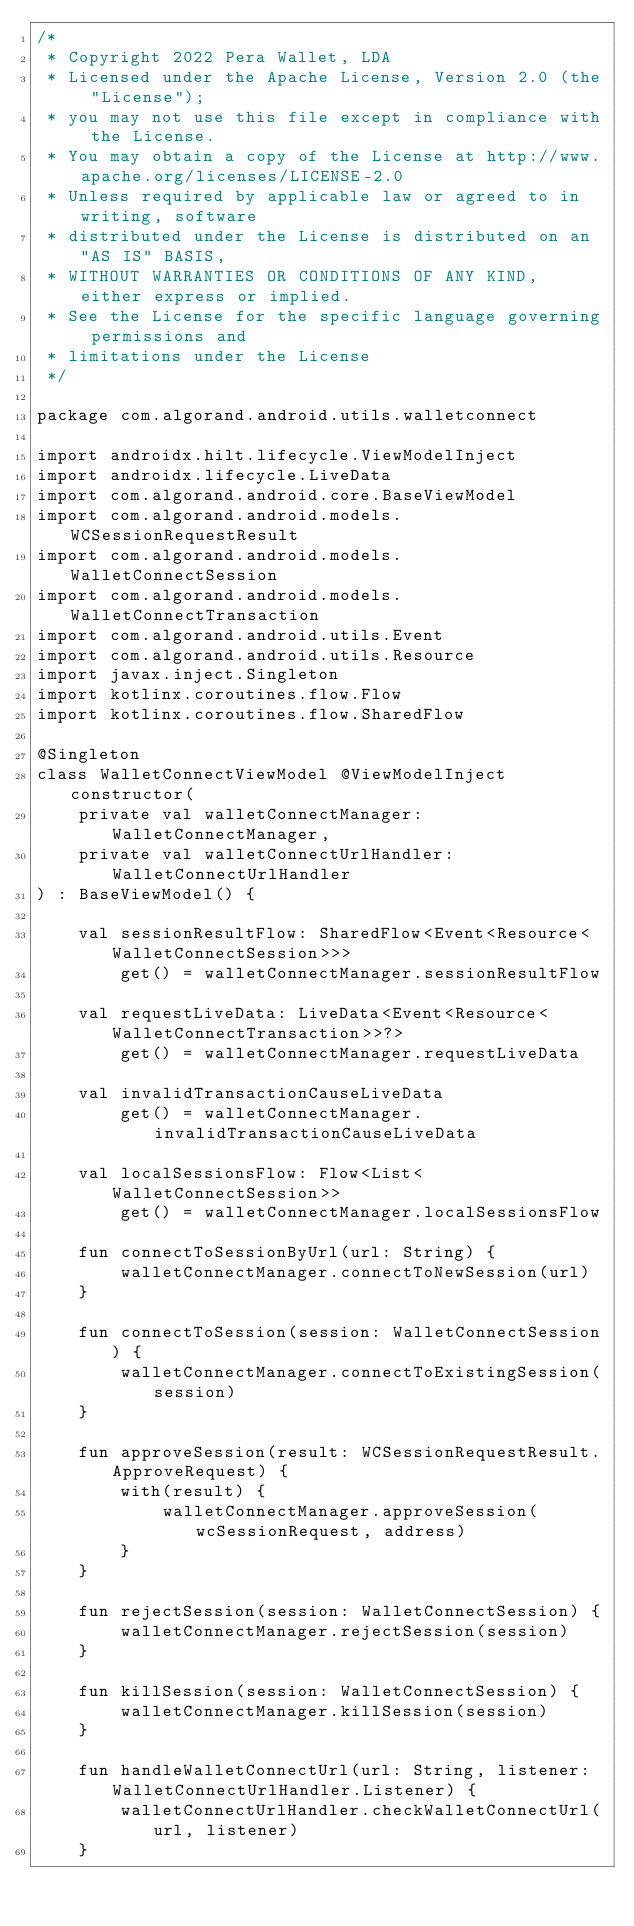<code> <loc_0><loc_0><loc_500><loc_500><_Kotlin_>/*
 * Copyright 2022 Pera Wallet, LDA
 * Licensed under the Apache License, Version 2.0 (the "License");
 * you may not use this file except in compliance with the License.
 * You may obtain a copy of the License at http://www.apache.org/licenses/LICENSE-2.0
 * Unless required by applicable law or agreed to in writing, software
 * distributed under the License is distributed on an "AS IS" BASIS,
 * WITHOUT WARRANTIES OR CONDITIONS OF ANY KIND, either express or implied.
 * See the License for the specific language governing permissions and
 * limitations under the License
 */

package com.algorand.android.utils.walletconnect

import androidx.hilt.lifecycle.ViewModelInject
import androidx.lifecycle.LiveData
import com.algorand.android.core.BaseViewModel
import com.algorand.android.models.WCSessionRequestResult
import com.algorand.android.models.WalletConnectSession
import com.algorand.android.models.WalletConnectTransaction
import com.algorand.android.utils.Event
import com.algorand.android.utils.Resource
import javax.inject.Singleton
import kotlinx.coroutines.flow.Flow
import kotlinx.coroutines.flow.SharedFlow

@Singleton
class WalletConnectViewModel @ViewModelInject constructor(
    private val walletConnectManager: WalletConnectManager,
    private val walletConnectUrlHandler: WalletConnectUrlHandler
) : BaseViewModel() {

    val sessionResultFlow: SharedFlow<Event<Resource<WalletConnectSession>>>
        get() = walletConnectManager.sessionResultFlow

    val requestLiveData: LiveData<Event<Resource<WalletConnectTransaction>>?>
        get() = walletConnectManager.requestLiveData

    val invalidTransactionCauseLiveData
        get() = walletConnectManager.invalidTransactionCauseLiveData

    val localSessionsFlow: Flow<List<WalletConnectSession>>
        get() = walletConnectManager.localSessionsFlow

    fun connectToSessionByUrl(url: String) {
        walletConnectManager.connectToNewSession(url)
    }

    fun connectToSession(session: WalletConnectSession) {
        walletConnectManager.connectToExistingSession(session)
    }

    fun approveSession(result: WCSessionRequestResult.ApproveRequest) {
        with(result) {
            walletConnectManager.approveSession(wcSessionRequest, address)
        }
    }

    fun rejectSession(session: WalletConnectSession) {
        walletConnectManager.rejectSession(session)
    }

    fun killSession(session: WalletConnectSession) {
        walletConnectManager.killSession(session)
    }

    fun handleWalletConnectUrl(url: String, listener: WalletConnectUrlHandler.Listener) {
        walletConnectUrlHandler.checkWalletConnectUrl(url, listener)
    }
</code> 